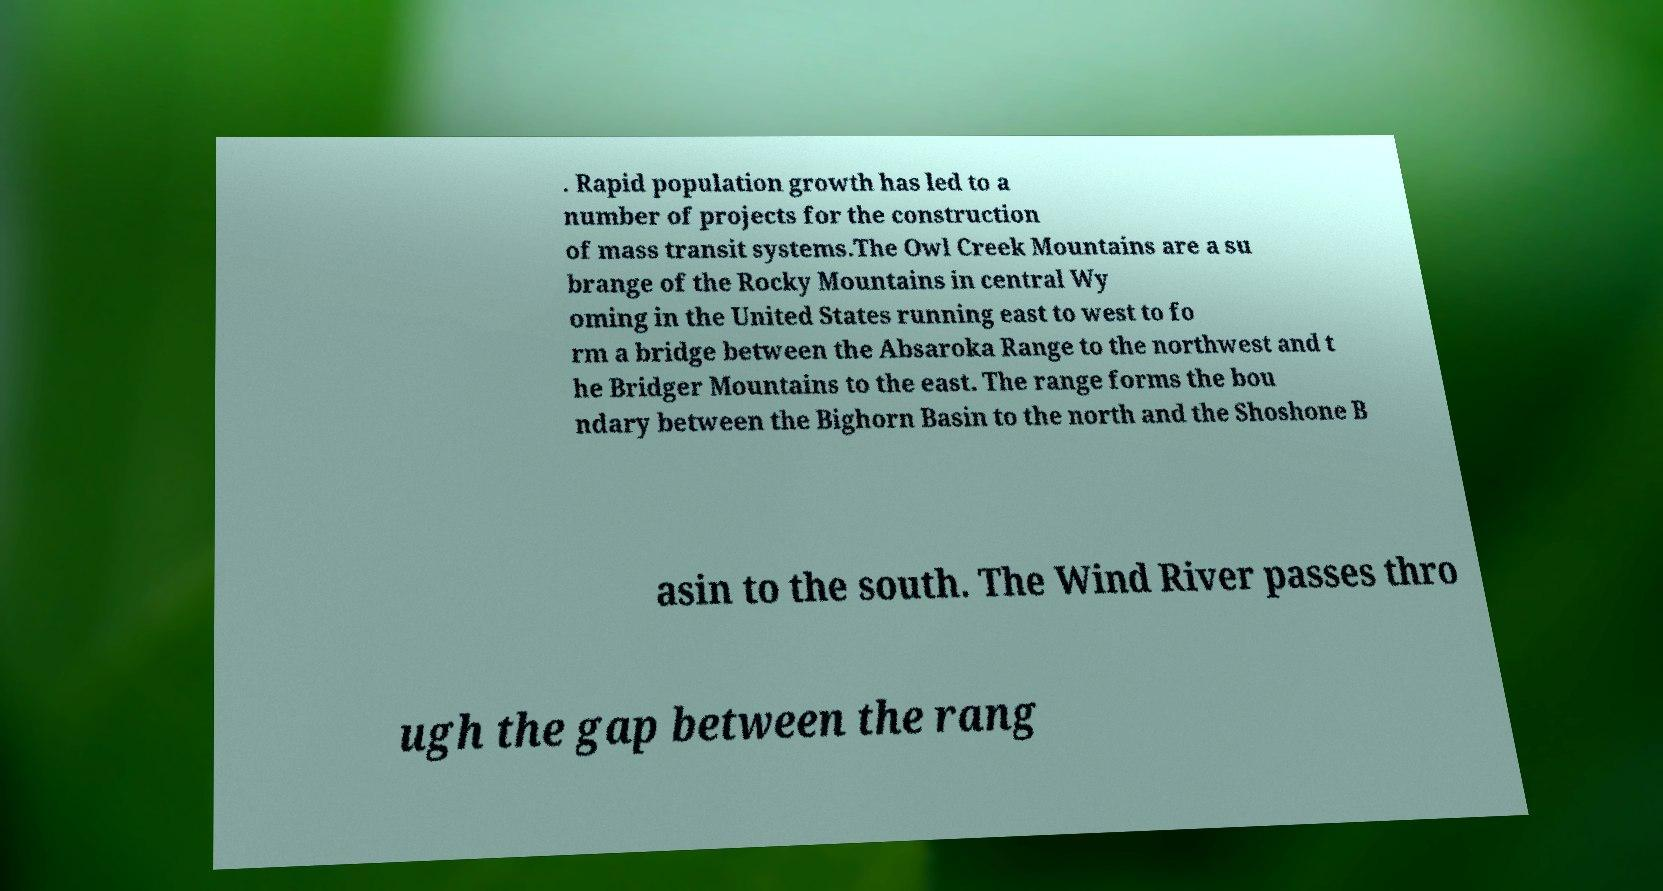Please identify and transcribe the text found in this image. . Rapid population growth has led to a number of projects for the construction of mass transit systems.The Owl Creek Mountains are a su brange of the Rocky Mountains in central Wy oming in the United States running east to west to fo rm a bridge between the Absaroka Range to the northwest and t he Bridger Mountains to the east. The range forms the bou ndary between the Bighorn Basin to the north and the Shoshone B asin to the south. The Wind River passes thro ugh the gap between the rang 